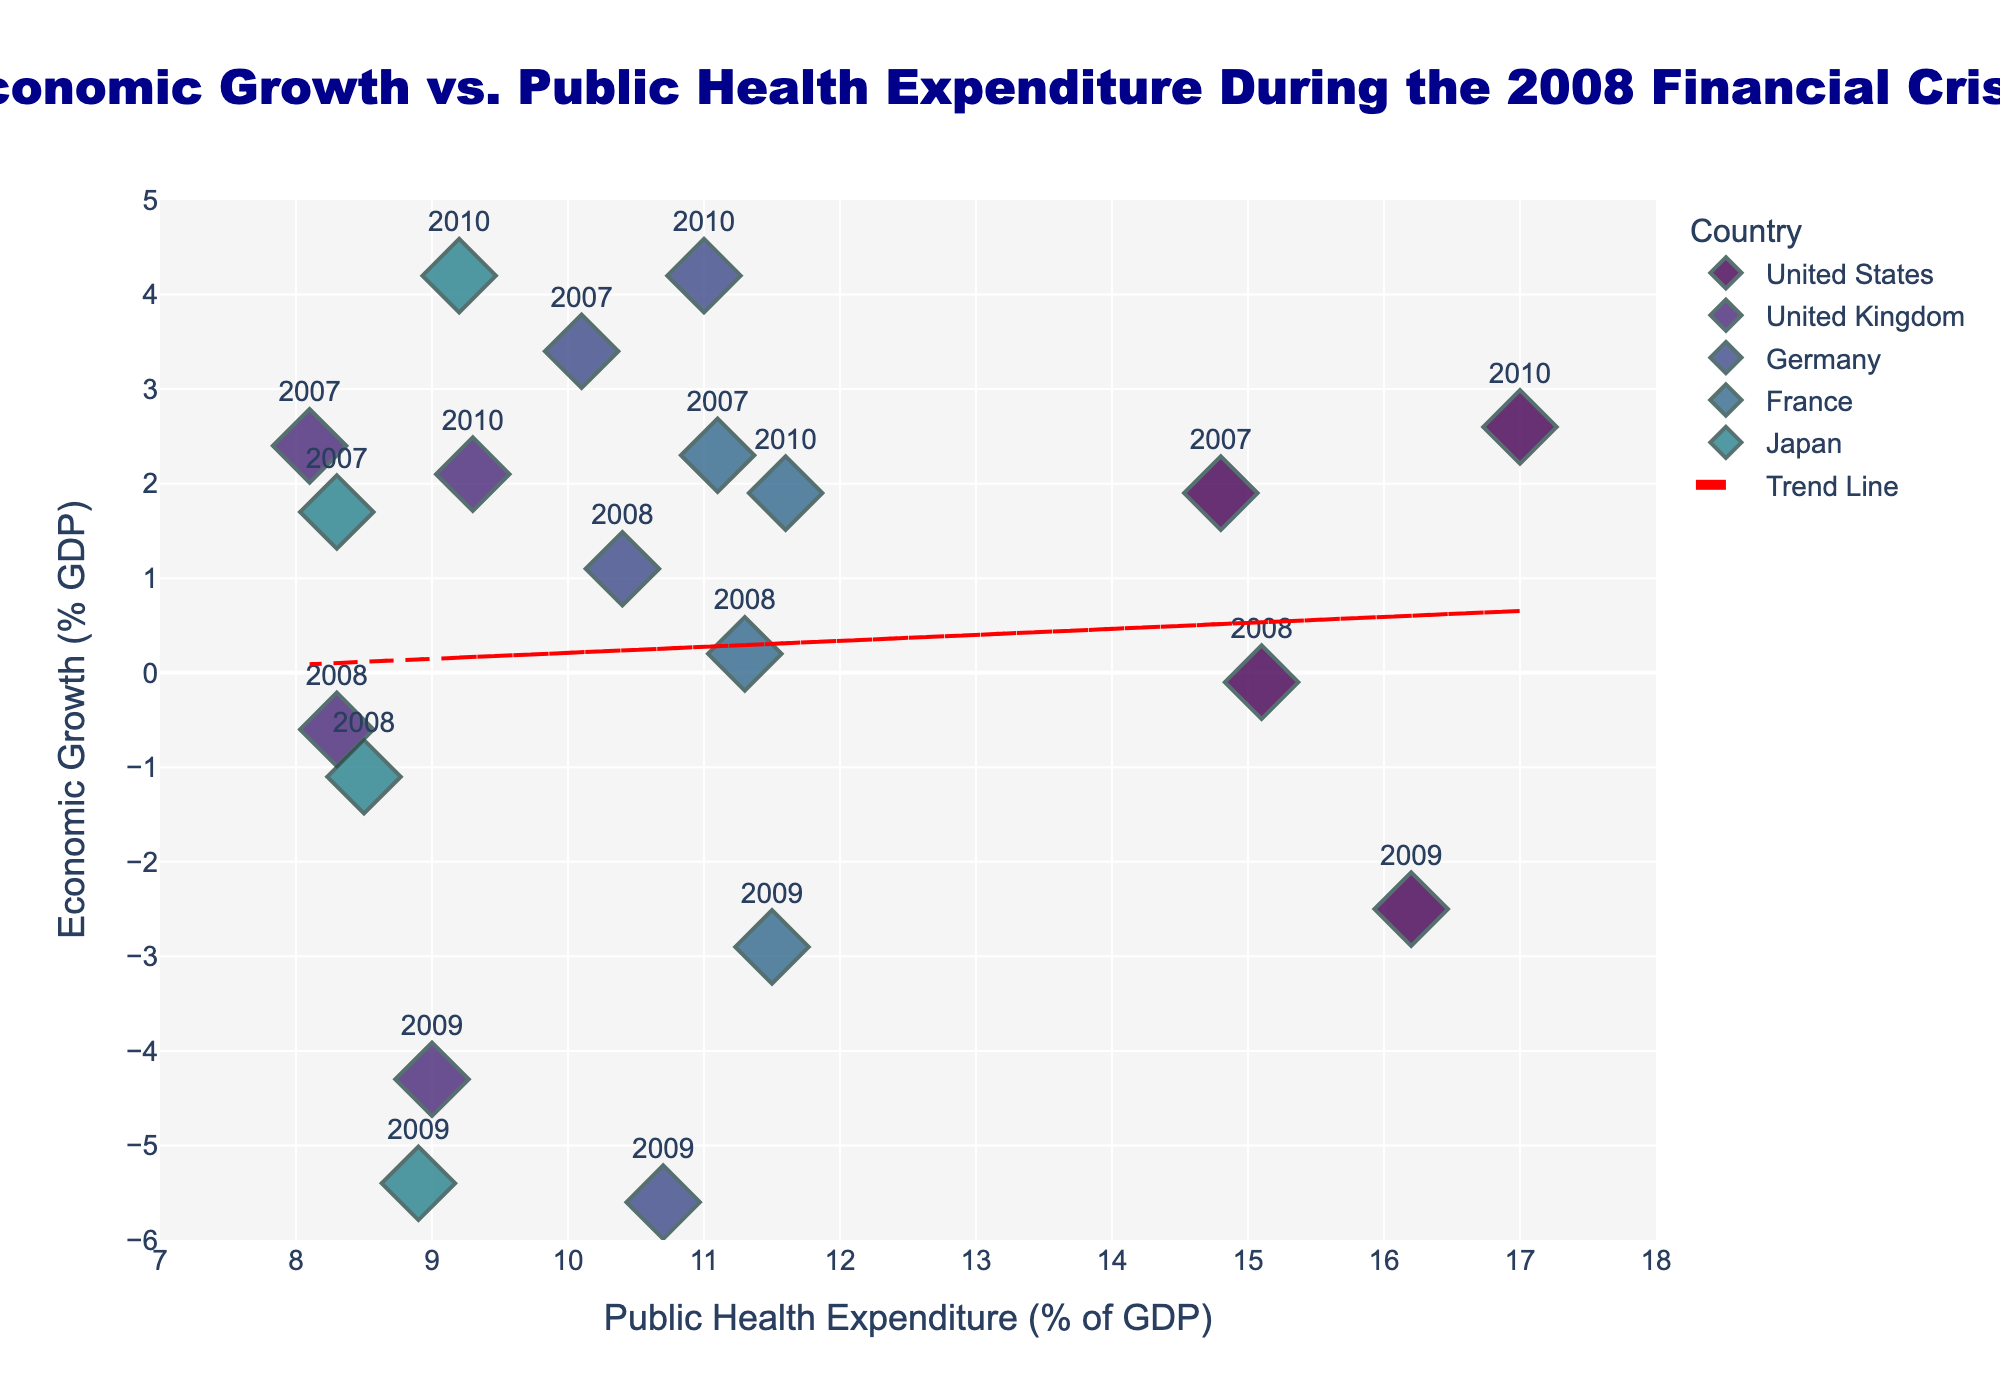What is the title of the figure? The title can be found at the top of the figure. It reads "Economic Growth vs. Public Health Expenditure During the 2008 Financial Crisis."
Answer: "Economic Growth vs. Public Health Expenditure During the 2008 Financial Crisis" Which country shows the highest public health expenditure for 2009? By looking at the public health expenditure marker for 2009, which is indicated by the year labels, the highest expenditure is for the United States in 2009.
Answer: United States What is the range of the x-axis? The x-axis range can be observed from the axis labels. It ranges from 7 to 18.
Answer: 7 to 18 Which year generally shows the lowest economic growth across all countries? We can see that 2009 markers generally cluster at the lower end of the y-axis, indicating lower economic growth.
Answer: 2009 Which country had a positive economic growth in 2009, if any? By examining the economic growth for each country in 2009, indicated by the year label "2009", none of the countries show positive economic growth.
Answer: None How does the trend line interpret the relationship between public health expenditure and economic growth? The trend line added in red shows a negative slope, indicating an inverse relationship, where higher public health expenditure generally corresponds to lower economic growth.
Answer: Inversely correlated Compare the economic growth of Germany and Japan in 2008. Which country had better performance? By locating the markers for Germany and Japan in 2008 on the vertical axis, Germany shows a positive economic growth (1.1%), while Japan shows negative growth (-1.1%). Thus, Germany had better performance.
Answer: Germany What is the average public health expenditure for 2008 across all countries? Adding the public health expenditure percentages for all countries in 2008 (15.1 + 8.3 + 10.4 + 11.3 + 8.5) gives 53.6. Dividing by 5 countries, the average is 10.72%.
Answer: 10.72% How did the economic growth of the United States change from 2007 to 2009? Observing the United States' economic growth markers, it declines from 1.9% in 2007 to -0.1% in 2008 and further to -2.5% in 2009.
Answer: Declined 